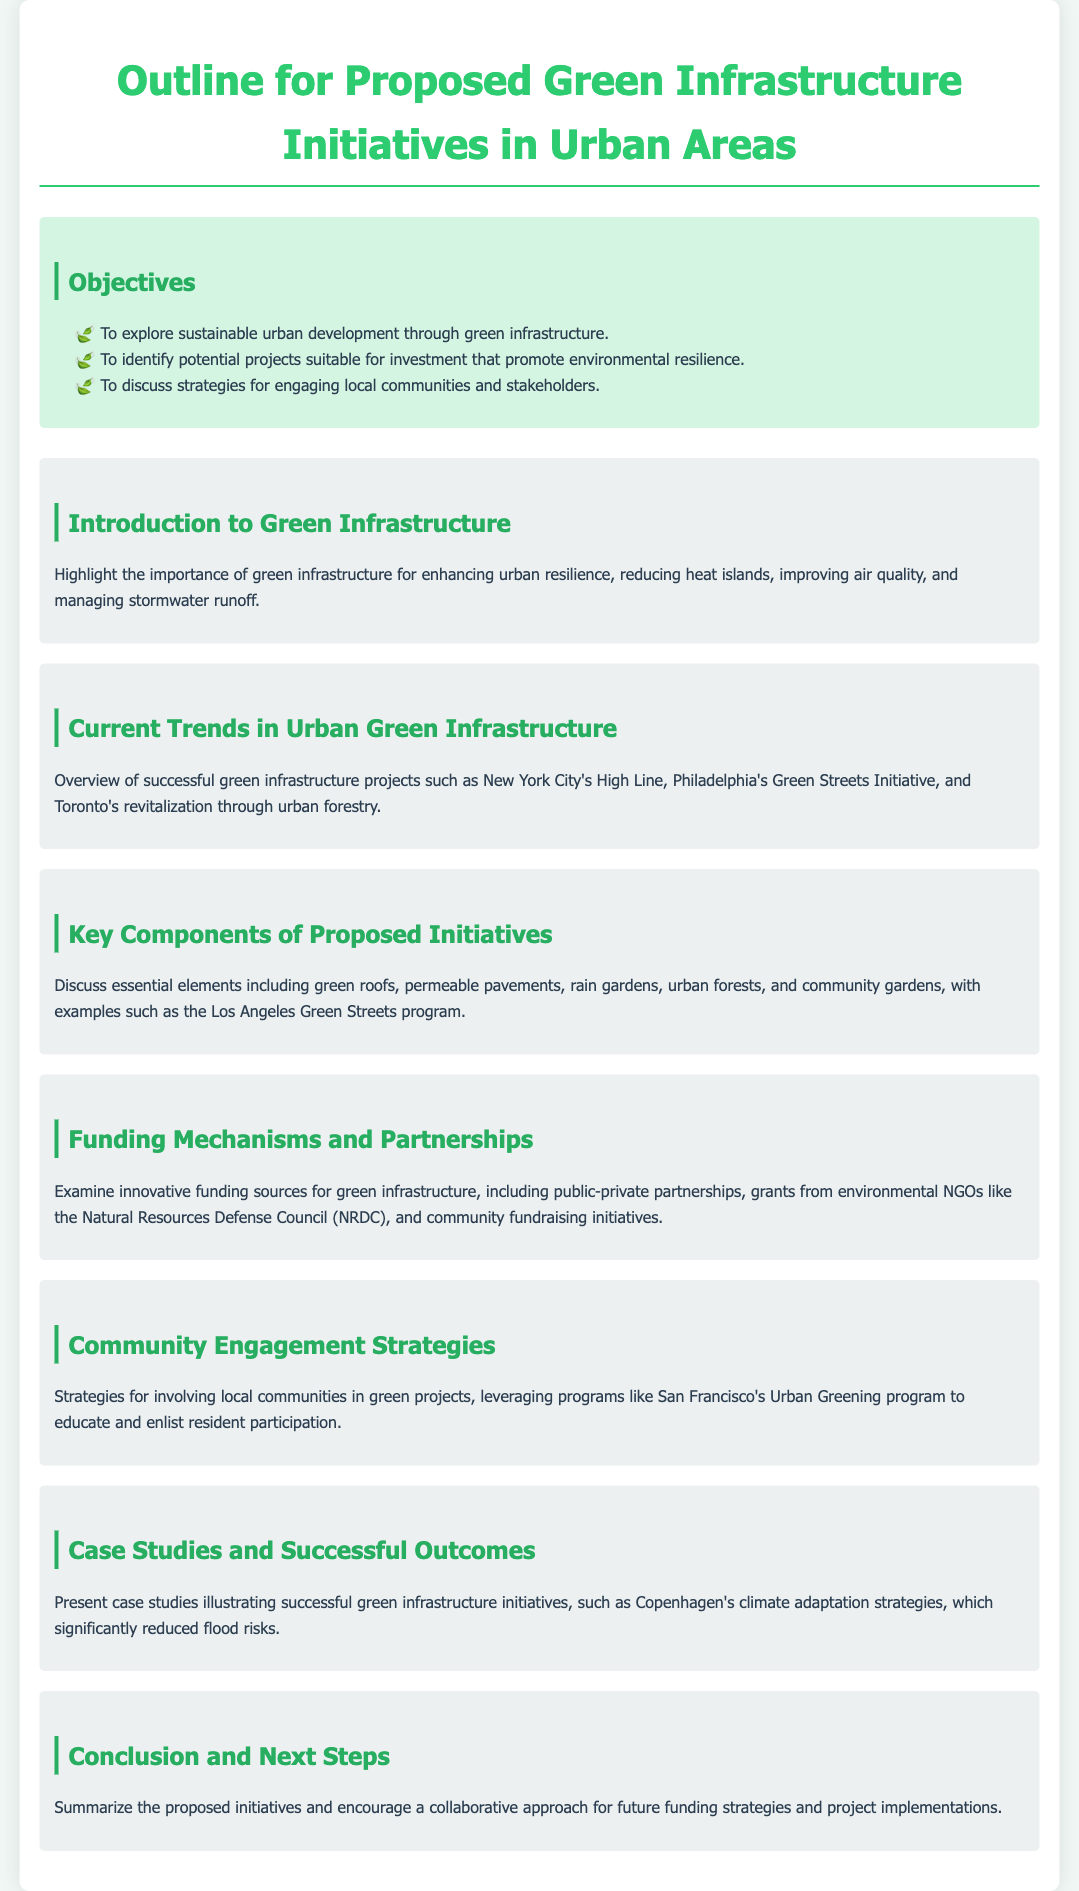What is the main goal of the initiatives? The document states that the main goal is exploring sustainable urban development through green infrastructure.
Answer: Sustainable urban development What is one of the key components mentioned for proposed initiatives? The document highlights essential elements such as green roofs, permeable pavements, and rain gardens.
Answer: Green roofs Which city is noted for its High Line project? The document mentions New York City in relation to the High Line project as a successful green infrastructure example.
Answer: New York City What innovative funding source is examined for green infrastructure? The document discusses public-private partnerships as one of the funding mechanisms for green initiatives.
Answer: Public-private partnerships What community engagement strategy is referenced? The document refers to San Francisco's Urban Greening program as a strategy for involving local communities in green projects.
Answer: Urban Greening program Which city implemented climate adaptation strategies that reduced flood risks? The document presents Copenhagen as a city that successfully implemented climate adaptation strategies.
Answer: Copenhagen What is a notable example of a green infrastructure project in Philadelphia? The document mentions Philadelphia's Green Streets Initiative as a successful example of green infrastructure.
Answer: Green Streets Initiative What is one objective of the proposed initiatives? One of the objectives discussed is to identify potential projects suitable for investment that promote environmental resilience.
Answer: Identify potential projects What is the importance of green infrastructure according to the document? The document highlights that green infrastructure enhances urban resilience, reduces heat islands, and improves air quality.
Answer: Enhances urban resilience 